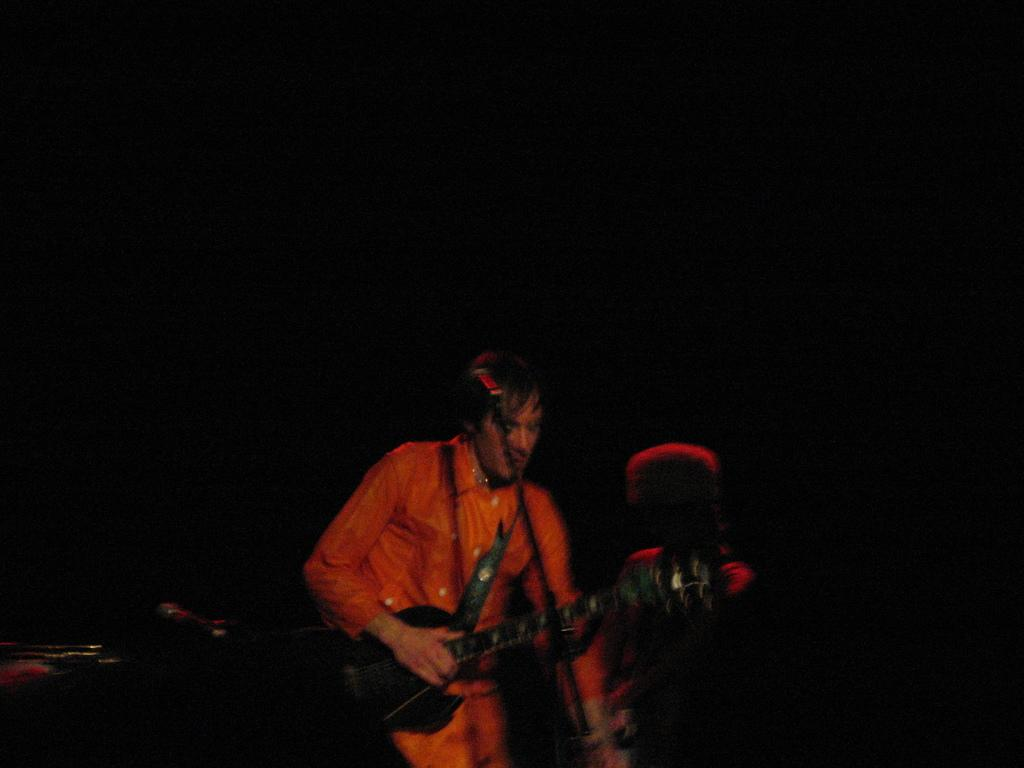What is the main subject of the image? There is a person in the image. What is the person wearing? The person is wearing an orange color shirt. What is the person holding in the image? The person is holding a guitar. What is the person's posture in the image? The person is standing. How would you describe the background of the image? The background of the image is dark in color. What type of toothbrush is the person using in the image? There is no toothbrush present in the image. What emotion does the person seem to be expressing while holding the guitar? The image does not convey any specific emotion, as it only shows the person holding a guitar and standing. 